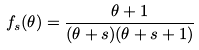Convert formula to latex. <formula><loc_0><loc_0><loc_500><loc_500>f _ { s } ( \theta ) = \frac { \theta + 1 } { ( \theta + s ) ( \theta + s + 1 ) }</formula> 